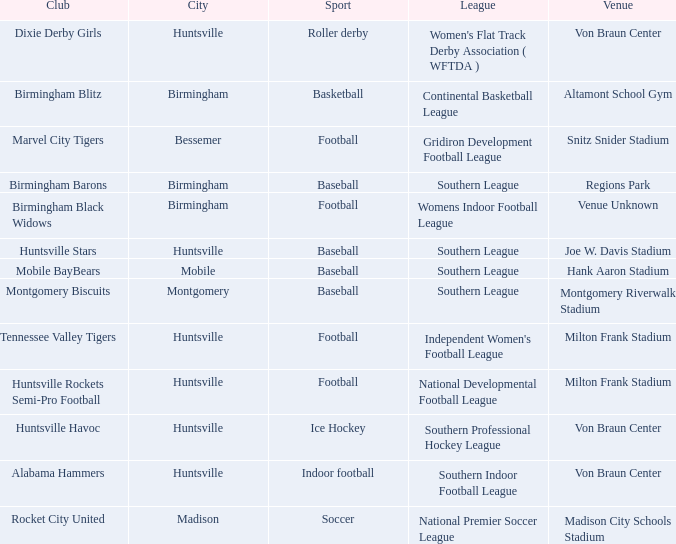Which venue hosted the Gridiron Development Football League? Snitz Snider Stadium. 